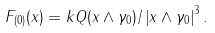Convert formula to latex. <formula><loc_0><loc_0><loc_500><loc_500>F _ { ( 0 ) } ( x ) = k Q ( x \wedge \gamma _ { 0 } ) / \left | x \wedge \gamma _ { 0 } \right | ^ { 3 } .</formula> 